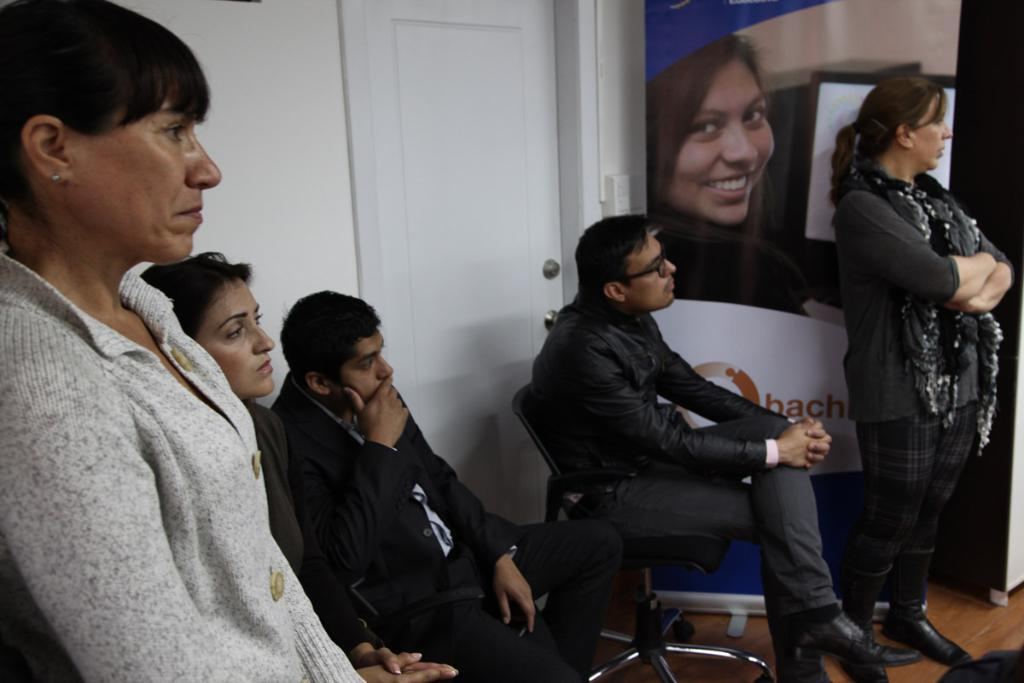How many people are present in the image? There are five people in the image. What can be seen hanging in the image? There is a banner in the image. What architectural feature is visible in the image? There is a door and a wall in the image. What type of furniture is present in the image? There are chairs in the image. What are the people in the image doing? Three people are sitting, and two people are standing in the image. What type of stem can be seen growing from the floor in the image? There is no stem growing from the floor in the image. How many clovers are being held by the people in the image? There are no clovers present in the image. 